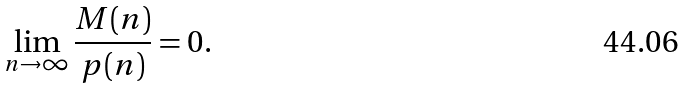Convert formula to latex. <formula><loc_0><loc_0><loc_500><loc_500>\lim _ { n \rightarrow \infty } \frac { M ( n ) } { p ( n ) } = 0 .</formula> 